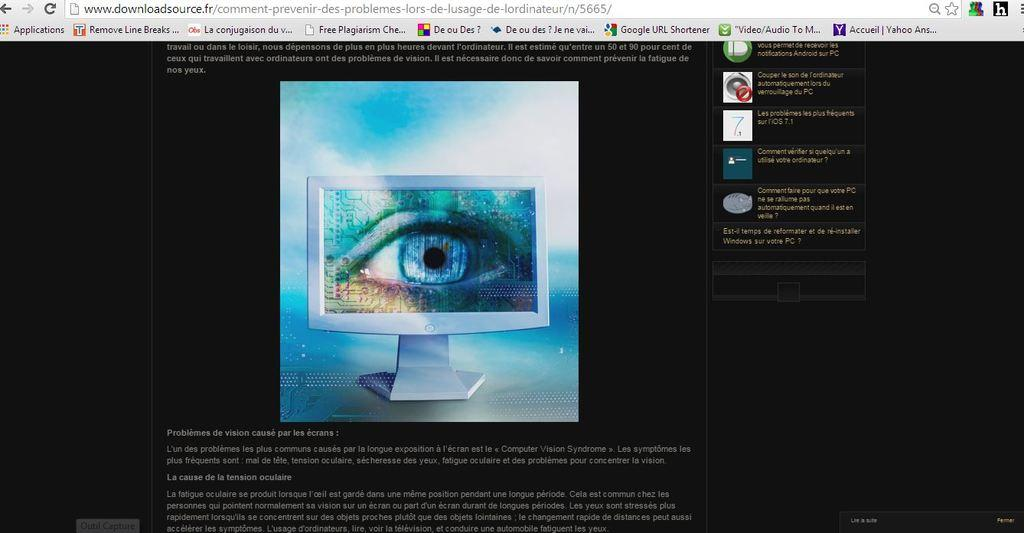Provide a one-sentence caption for the provided image. a computer screen with a window open  to www.downloadsource.fr/. 